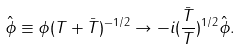<formula> <loc_0><loc_0><loc_500><loc_500>\hat { \phi } \equiv \phi ( T + \bar { T } ) ^ { - 1 / 2 } \rightarrow - i ( \frac { \bar { T } } { T } ) ^ { 1 / 2 } \hat { \phi } .</formula> 